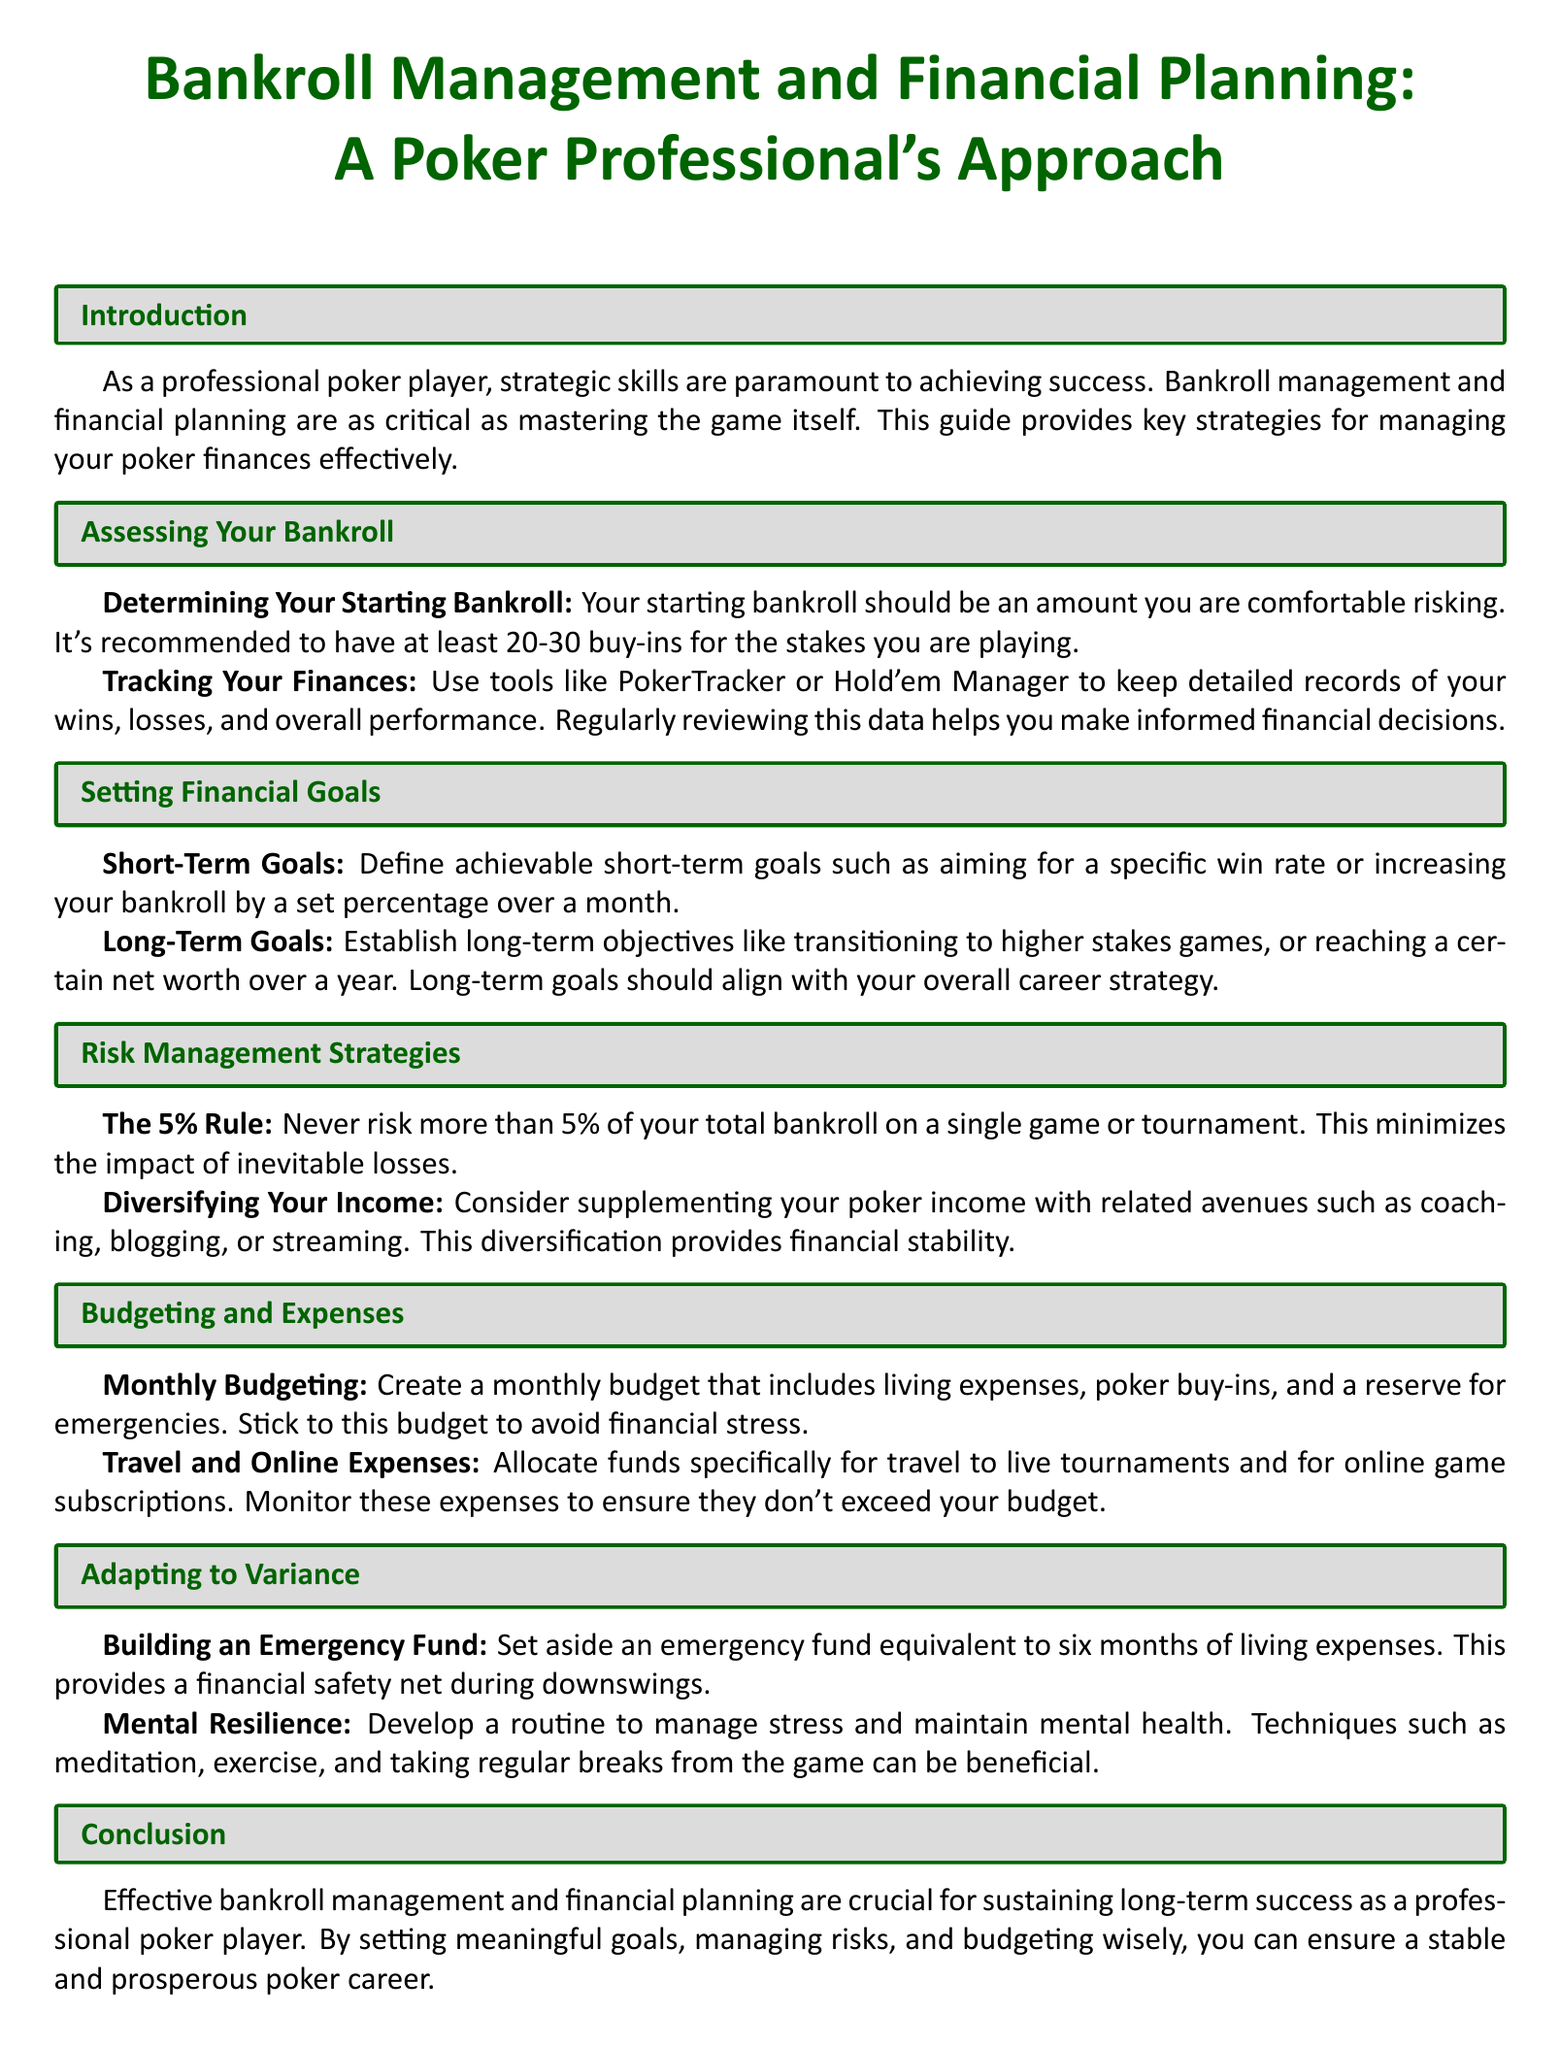What is the recommended number of buy-ins for your starting bankroll? The document suggests having at least 20-30 buy-ins for the stakes you are playing.
Answer: 20-30 buy-ins What is the 5% rule? The 5% rule states to never risk more than 5% of your total bankroll on a single game or tournament to minimize losses.
Answer: 5% What should you track to keep detailed records of your poker performance? You should track wins, losses, and overall performance using tools like PokerTracker or Hold'em Manager.
Answer: Wins and losses What is a suggested amount for building an emergency fund? The document recommends setting aside an emergency fund equivalent to six months of living expenses.
Answer: Six months What are short-term goals supposed to aim for? Short-term goals should aim for achievements like a specific win rate or increasing your bankroll by a set percentage over a month.
Answer: Specific win rate What diversifying strategy is suggested besides playing poker? Supplement your poker income with related avenues such as coaching, blogging, or streaming.
Answer: Coaching, blogging, or streaming What should be included in a monthly budget? A monthly budget should include living expenses, poker buy-ins, and a reserve for emergencies.
Answer: Living expenses Which techniques are recommended for managing mental resilience? Techniques such as meditation, exercise, and taking regular breaks from the game are recommended.
Answer: Meditation, exercise What is the main focus of the document? The main focus is on effective bankroll management and financial planning for sustaining long-term success as a professional poker player.
Answer: Bankroll management and financial planning 